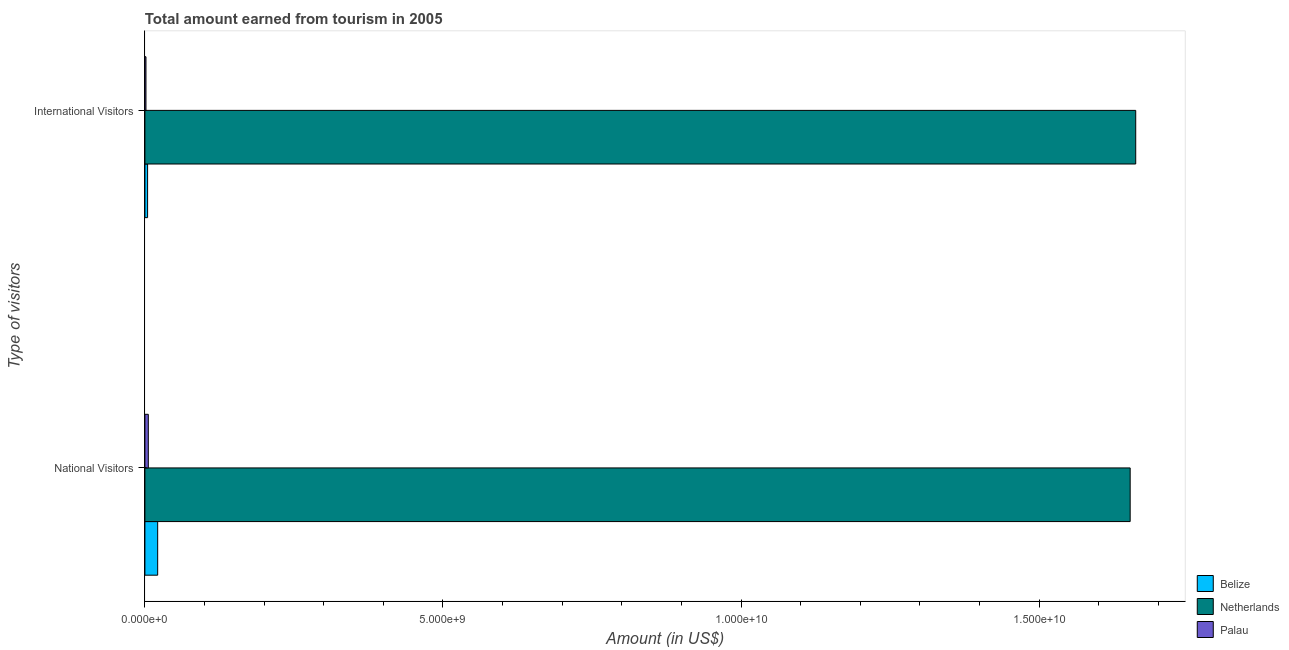Are the number of bars per tick equal to the number of legend labels?
Make the answer very short. Yes. Are the number of bars on each tick of the Y-axis equal?
Offer a terse response. Yes. How many bars are there on the 2nd tick from the top?
Make the answer very short. 3. How many bars are there on the 1st tick from the bottom?
Provide a succinct answer. 3. What is the label of the 2nd group of bars from the top?
Offer a terse response. National Visitors. What is the amount earned from national visitors in Belize?
Keep it short and to the point. 2.14e+08. Across all countries, what is the maximum amount earned from international visitors?
Offer a very short reply. 1.66e+1. Across all countries, what is the minimum amount earned from national visitors?
Your answer should be very brief. 5.70e+07. In which country was the amount earned from national visitors maximum?
Offer a terse response. Netherlands. In which country was the amount earned from international visitors minimum?
Provide a succinct answer. Palau. What is the total amount earned from national visitors in the graph?
Your answer should be very brief. 1.68e+1. What is the difference between the amount earned from international visitors in Palau and that in Netherlands?
Ensure brevity in your answer.  -1.66e+1. What is the difference between the amount earned from international visitors in Belize and the amount earned from national visitors in Netherlands?
Offer a terse response. -1.65e+1. What is the average amount earned from national visitors per country?
Keep it short and to the point. 5.60e+09. What is the difference between the amount earned from international visitors and amount earned from national visitors in Netherlands?
Make the answer very short. 9.30e+07. In how many countries, is the amount earned from international visitors greater than 11000000000 US$?
Make the answer very short. 1. What is the ratio of the amount earned from international visitors in Palau to that in Netherlands?
Give a very brief answer. 0. Is the amount earned from international visitors in Belize less than that in Palau?
Give a very brief answer. No. In how many countries, is the amount earned from international visitors greater than the average amount earned from international visitors taken over all countries?
Offer a very short reply. 1. What does the 2nd bar from the top in International Visitors represents?
Give a very brief answer. Netherlands. How many bars are there?
Keep it short and to the point. 6. How many countries are there in the graph?
Keep it short and to the point. 3. What is the difference between two consecutive major ticks on the X-axis?
Provide a succinct answer. 5.00e+09. Does the graph contain any zero values?
Your response must be concise. No. Does the graph contain grids?
Keep it short and to the point. No. What is the title of the graph?
Provide a short and direct response. Total amount earned from tourism in 2005. What is the label or title of the X-axis?
Provide a short and direct response. Amount (in US$). What is the label or title of the Y-axis?
Your answer should be very brief. Type of visitors. What is the Amount (in US$) of Belize in National Visitors?
Your response must be concise. 2.14e+08. What is the Amount (in US$) in Netherlands in National Visitors?
Make the answer very short. 1.65e+1. What is the Amount (in US$) of Palau in National Visitors?
Provide a short and direct response. 5.70e+07. What is the Amount (in US$) of Belize in International Visitors?
Provide a short and direct response. 4.50e+07. What is the Amount (in US$) in Netherlands in International Visitors?
Offer a terse response. 1.66e+1. What is the Amount (in US$) in Palau in International Visitors?
Keep it short and to the point. 1.77e+07. Across all Type of visitors, what is the maximum Amount (in US$) in Belize?
Ensure brevity in your answer.  2.14e+08. Across all Type of visitors, what is the maximum Amount (in US$) of Netherlands?
Keep it short and to the point. 1.66e+1. Across all Type of visitors, what is the maximum Amount (in US$) in Palau?
Your answer should be compact. 5.70e+07. Across all Type of visitors, what is the minimum Amount (in US$) of Belize?
Offer a terse response. 4.50e+07. Across all Type of visitors, what is the minimum Amount (in US$) of Netherlands?
Ensure brevity in your answer.  1.65e+1. Across all Type of visitors, what is the minimum Amount (in US$) in Palau?
Provide a succinct answer. 1.77e+07. What is the total Amount (in US$) in Belize in the graph?
Ensure brevity in your answer.  2.59e+08. What is the total Amount (in US$) of Netherlands in the graph?
Make the answer very short. 3.31e+1. What is the total Amount (in US$) of Palau in the graph?
Your answer should be very brief. 7.47e+07. What is the difference between the Amount (in US$) in Belize in National Visitors and that in International Visitors?
Provide a short and direct response. 1.69e+08. What is the difference between the Amount (in US$) of Netherlands in National Visitors and that in International Visitors?
Make the answer very short. -9.30e+07. What is the difference between the Amount (in US$) in Palau in National Visitors and that in International Visitors?
Make the answer very short. 3.93e+07. What is the difference between the Amount (in US$) of Belize in National Visitors and the Amount (in US$) of Netherlands in International Visitors?
Give a very brief answer. -1.64e+1. What is the difference between the Amount (in US$) of Belize in National Visitors and the Amount (in US$) of Palau in International Visitors?
Your response must be concise. 1.96e+08. What is the difference between the Amount (in US$) of Netherlands in National Visitors and the Amount (in US$) of Palau in International Visitors?
Your answer should be very brief. 1.65e+1. What is the average Amount (in US$) in Belize per Type of visitors?
Give a very brief answer. 1.30e+08. What is the average Amount (in US$) of Netherlands per Type of visitors?
Your answer should be very brief. 1.66e+1. What is the average Amount (in US$) of Palau per Type of visitors?
Provide a short and direct response. 3.74e+07. What is the difference between the Amount (in US$) of Belize and Amount (in US$) of Netherlands in National Visitors?
Provide a succinct answer. -1.63e+1. What is the difference between the Amount (in US$) in Belize and Amount (in US$) in Palau in National Visitors?
Your answer should be very brief. 1.57e+08. What is the difference between the Amount (in US$) of Netherlands and Amount (in US$) of Palau in National Visitors?
Your answer should be compact. 1.65e+1. What is the difference between the Amount (in US$) of Belize and Amount (in US$) of Netherlands in International Visitors?
Your response must be concise. -1.66e+1. What is the difference between the Amount (in US$) in Belize and Amount (in US$) in Palau in International Visitors?
Keep it short and to the point. 2.73e+07. What is the difference between the Amount (in US$) in Netherlands and Amount (in US$) in Palau in International Visitors?
Offer a very short reply. 1.66e+1. What is the ratio of the Amount (in US$) of Belize in National Visitors to that in International Visitors?
Your answer should be very brief. 4.76. What is the ratio of the Amount (in US$) in Netherlands in National Visitors to that in International Visitors?
Provide a short and direct response. 0.99. What is the ratio of the Amount (in US$) in Palau in National Visitors to that in International Visitors?
Provide a succinct answer. 3.22. What is the difference between the highest and the second highest Amount (in US$) of Belize?
Ensure brevity in your answer.  1.69e+08. What is the difference between the highest and the second highest Amount (in US$) in Netherlands?
Give a very brief answer. 9.30e+07. What is the difference between the highest and the second highest Amount (in US$) in Palau?
Provide a succinct answer. 3.93e+07. What is the difference between the highest and the lowest Amount (in US$) in Belize?
Your answer should be very brief. 1.69e+08. What is the difference between the highest and the lowest Amount (in US$) in Netherlands?
Offer a very short reply. 9.30e+07. What is the difference between the highest and the lowest Amount (in US$) in Palau?
Your response must be concise. 3.93e+07. 